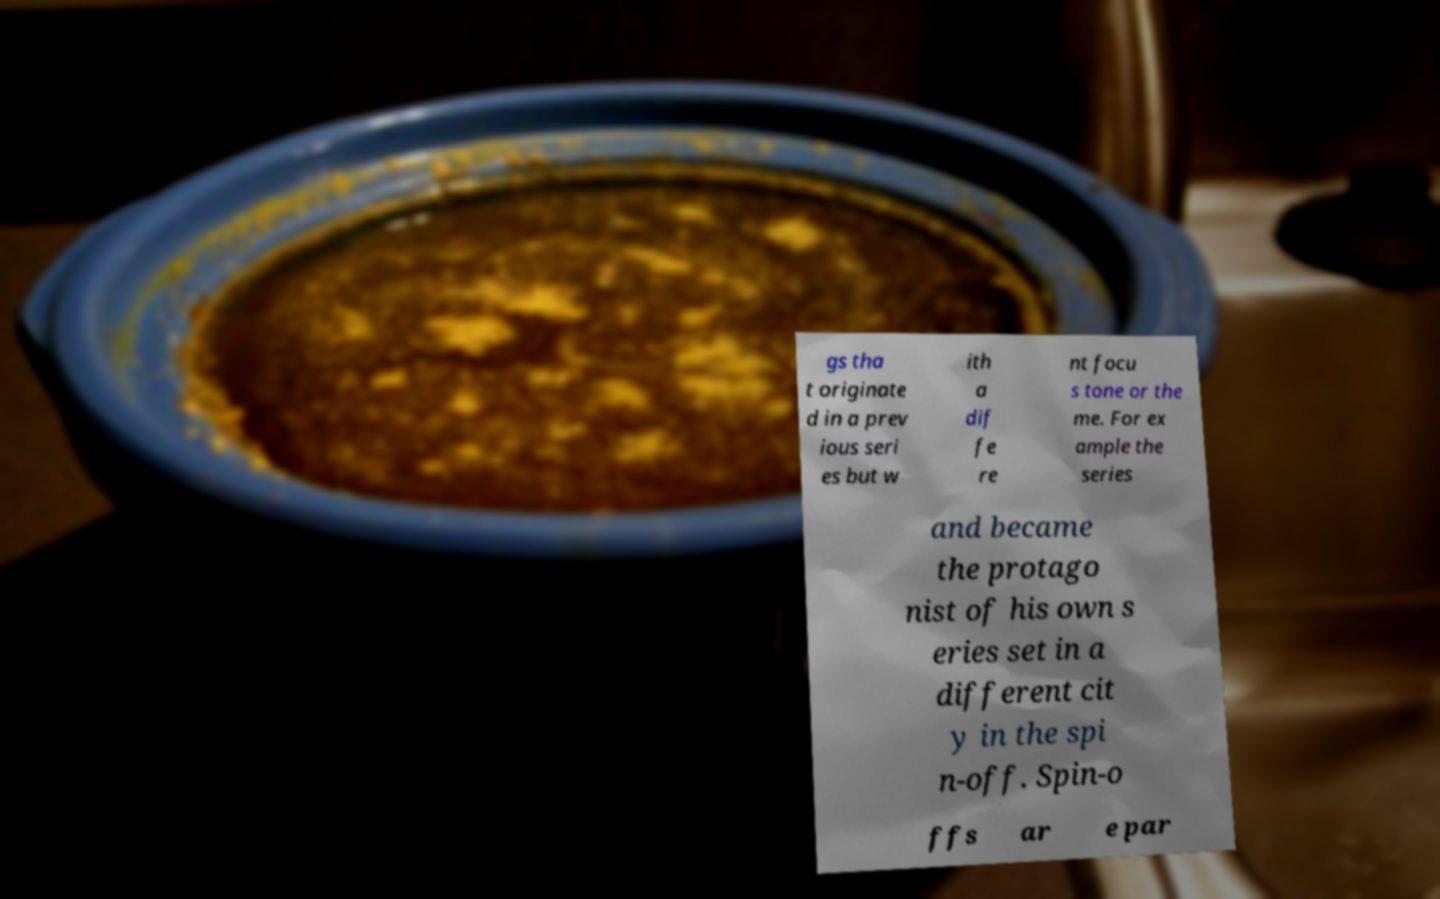There's text embedded in this image that I need extracted. Can you transcribe it verbatim? gs tha t originate d in a prev ious seri es but w ith a dif fe re nt focu s tone or the me. For ex ample the series and became the protago nist of his own s eries set in a different cit y in the spi n-off. Spin-o ffs ar e par 